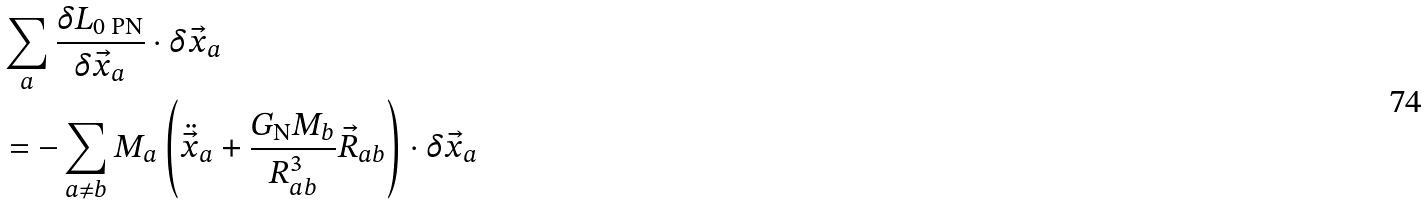<formula> <loc_0><loc_0><loc_500><loc_500>& \sum _ { a } \frac { \delta L _ { \text {0 PN} } } { \delta \vec { x } _ { a } } \cdot \delta \vec { x } _ { a } \\ & = - \sum _ { a \neq b } M _ { a } \left ( \ddot { \vec { x } } _ { a } + \frac { G _ { \text {N} } M _ { b } } { R _ { a b } ^ { 3 } } \vec { R } _ { a b } \right ) \cdot \delta \vec { x } _ { a }</formula> 